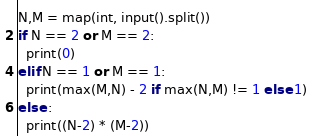<code> <loc_0><loc_0><loc_500><loc_500><_Python_>N,M = map(int, input().split())
if N == 2 or M == 2:
  print(0)
elif N == 1 or M == 1:
  print(max(M,N) - 2 if max(N,M) != 1 else 1)
else :
  print((N-2) * (M-2))</code> 